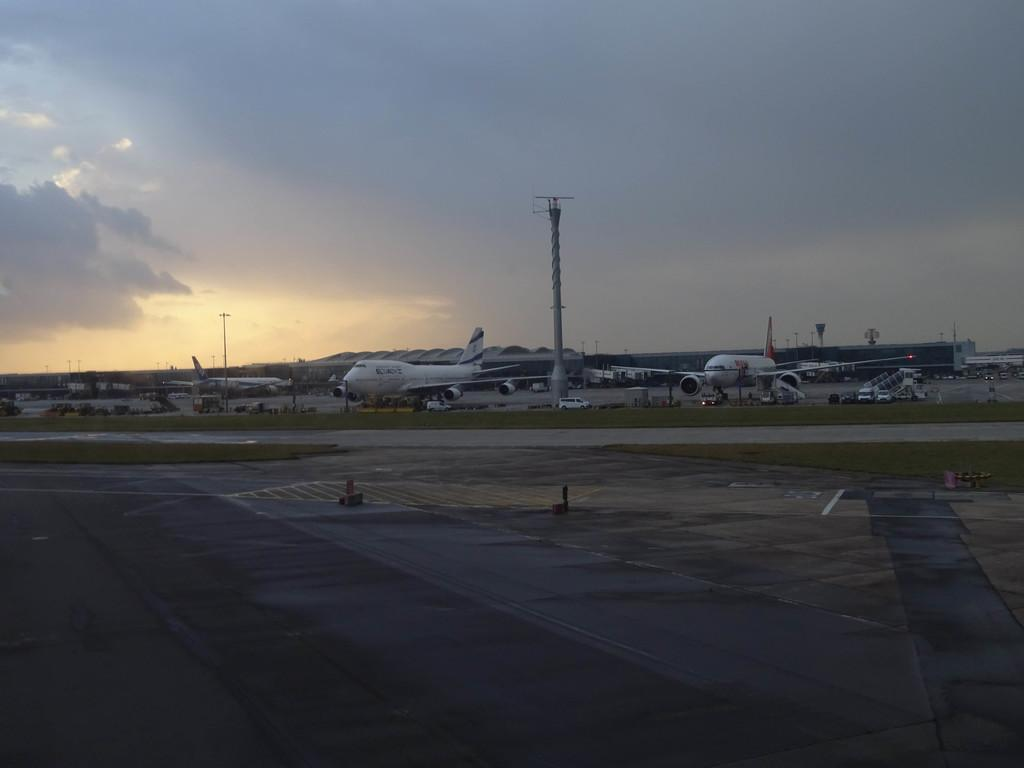What is the main subject of the image? The main subject of the image is flights. What can be seen in the background of the image? There is a sky visible in the background of the image. What type of brick is being used to build the payment system in the image? There is no brick or payment system present in the image; it features flights and a sky. How often do the toothbrushes need to be replaced in the image? There are no toothbrushes present in the image. 